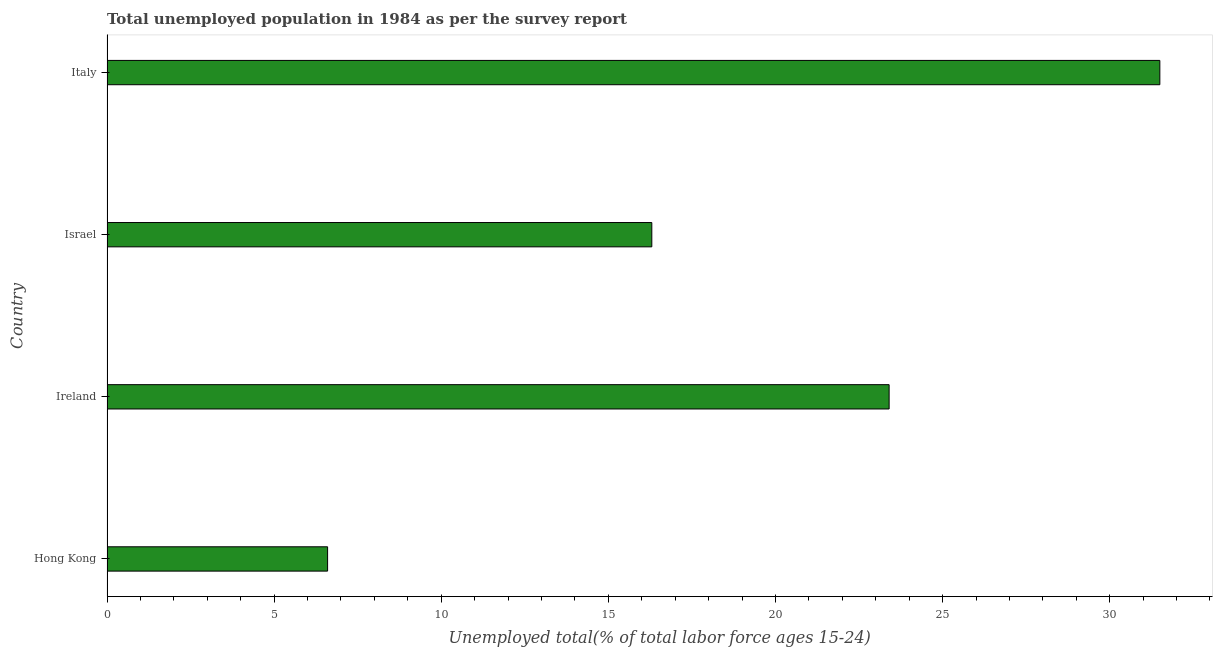What is the title of the graph?
Give a very brief answer. Total unemployed population in 1984 as per the survey report. What is the label or title of the X-axis?
Your answer should be very brief. Unemployed total(% of total labor force ages 15-24). What is the unemployed youth in Italy?
Your answer should be compact. 31.5. Across all countries, what is the maximum unemployed youth?
Your answer should be very brief. 31.5. Across all countries, what is the minimum unemployed youth?
Provide a short and direct response. 6.6. In which country was the unemployed youth maximum?
Keep it short and to the point. Italy. In which country was the unemployed youth minimum?
Give a very brief answer. Hong Kong. What is the sum of the unemployed youth?
Your answer should be compact. 77.8. What is the difference between the unemployed youth in Hong Kong and Italy?
Keep it short and to the point. -24.9. What is the average unemployed youth per country?
Your response must be concise. 19.45. What is the median unemployed youth?
Provide a succinct answer. 19.85. What is the ratio of the unemployed youth in Hong Kong to that in Ireland?
Provide a succinct answer. 0.28. Is the unemployed youth in Hong Kong less than that in Ireland?
Offer a terse response. Yes. Is the sum of the unemployed youth in Hong Kong and Israel greater than the maximum unemployed youth across all countries?
Make the answer very short. No. What is the difference between the highest and the lowest unemployed youth?
Your answer should be compact. 24.9. How many bars are there?
Ensure brevity in your answer.  4. Are all the bars in the graph horizontal?
Offer a terse response. Yes. What is the Unemployed total(% of total labor force ages 15-24) in Hong Kong?
Ensure brevity in your answer.  6.6. What is the Unemployed total(% of total labor force ages 15-24) of Ireland?
Make the answer very short. 23.4. What is the Unemployed total(% of total labor force ages 15-24) of Israel?
Give a very brief answer. 16.3. What is the Unemployed total(% of total labor force ages 15-24) in Italy?
Give a very brief answer. 31.5. What is the difference between the Unemployed total(% of total labor force ages 15-24) in Hong Kong and Ireland?
Make the answer very short. -16.8. What is the difference between the Unemployed total(% of total labor force ages 15-24) in Hong Kong and Italy?
Provide a short and direct response. -24.9. What is the difference between the Unemployed total(% of total labor force ages 15-24) in Israel and Italy?
Make the answer very short. -15.2. What is the ratio of the Unemployed total(% of total labor force ages 15-24) in Hong Kong to that in Ireland?
Ensure brevity in your answer.  0.28. What is the ratio of the Unemployed total(% of total labor force ages 15-24) in Hong Kong to that in Israel?
Give a very brief answer. 0.41. What is the ratio of the Unemployed total(% of total labor force ages 15-24) in Hong Kong to that in Italy?
Provide a succinct answer. 0.21. What is the ratio of the Unemployed total(% of total labor force ages 15-24) in Ireland to that in Israel?
Make the answer very short. 1.44. What is the ratio of the Unemployed total(% of total labor force ages 15-24) in Ireland to that in Italy?
Provide a succinct answer. 0.74. What is the ratio of the Unemployed total(% of total labor force ages 15-24) in Israel to that in Italy?
Your answer should be compact. 0.52. 